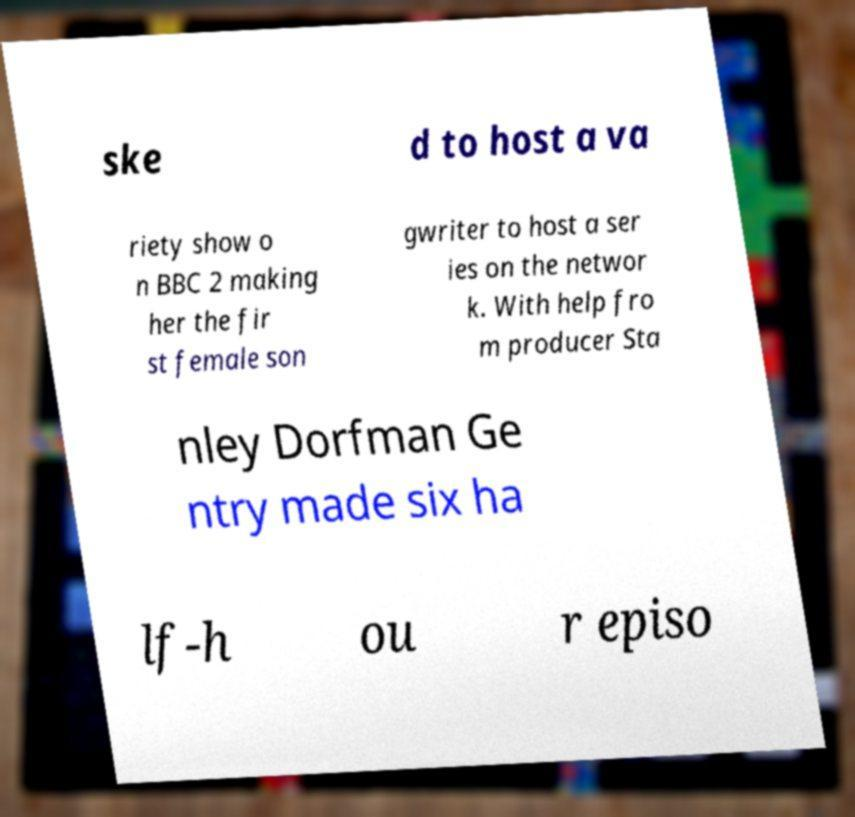I need the written content from this picture converted into text. Can you do that? ske d to host a va riety show o n BBC 2 making her the fir st female son gwriter to host a ser ies on the networ k. With help fro m producer Sta nley Dorfman Ge ntry made six ha lf-h ou r episo 